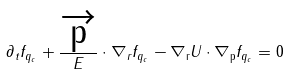<formula> <loc_0><loc_0><loc_500><loc_500>\partial _ { t } f _ { q _ { c } } + \frac { \overrightarrow { \text {p} } } { E } \cdot \nabla _ { r } f _ { q _ { c } } - \nabla _ { \text {r} } U \cdot \nabla _ { \text {p} } f _ { q _ { c } } = 0</formula> 